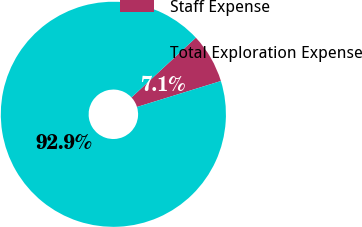Convert chart. <chart><loc_0><loc_0><loc_500><loc_500><pie_chart><fcel>Staff Expense<fcel>Total Exploration Expense<nl><fcel>7.14%<fcel>92.86%<nl></chart> 